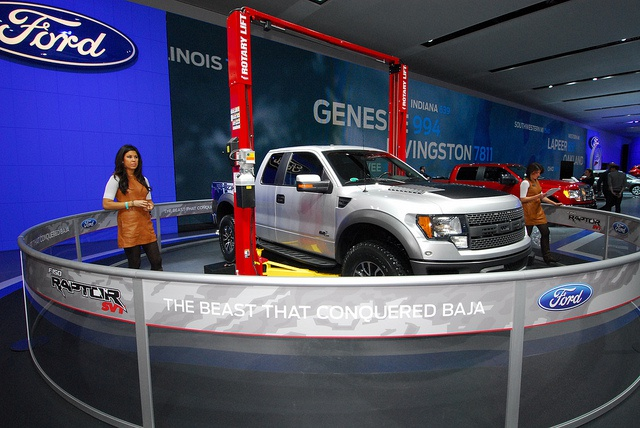Describe the objects in this image and their specific colors. I can see truck in navy, black, gray, white, and darkgray tones, people in navy, brown, black, and maroon tones, car in navy, black, maroon, and gray tones, truck in navy, black, maroon, and gray tones, and people in navy, black, maroon, brown, and darkgray tones in this image. 